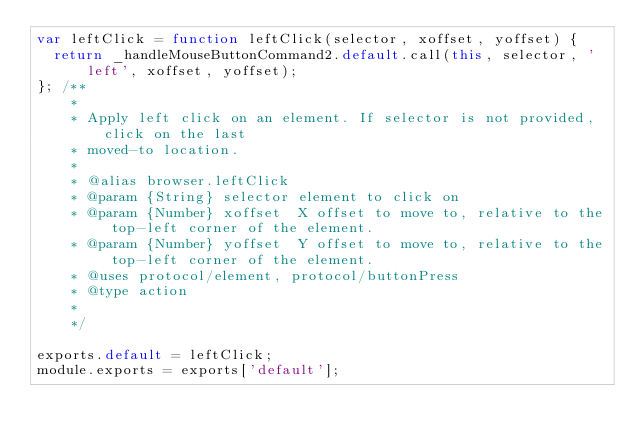Convert code to text. <code><loc_0><loc_0><loc_500><loc_500><_JavaScript_>var leftClick = function leftClick(selector, xoffset, yoffset) {
  return _handleMouseButtonCommand2.default.call(this, selector, 'left', xoffset, yoffset);
}; /**
    *
    * Apply left click on an element. If selector is not provided, click on the last
    * moved-to location.
    *
    * @alias browser.leftClick
    * @param {String} selector element to click on
    * @param {Number} xoffset  X offset to move to, relative to the top-left corner of the element.
    * @param {Number} yoffset  Y offset to move to, relative to the top-left corner of the element.
    * @uses protocol/element, protocol/buttonPress
    * @type action
    *
    */

exports.default = leftClick;
module.exports = exports['default'];
</code> 